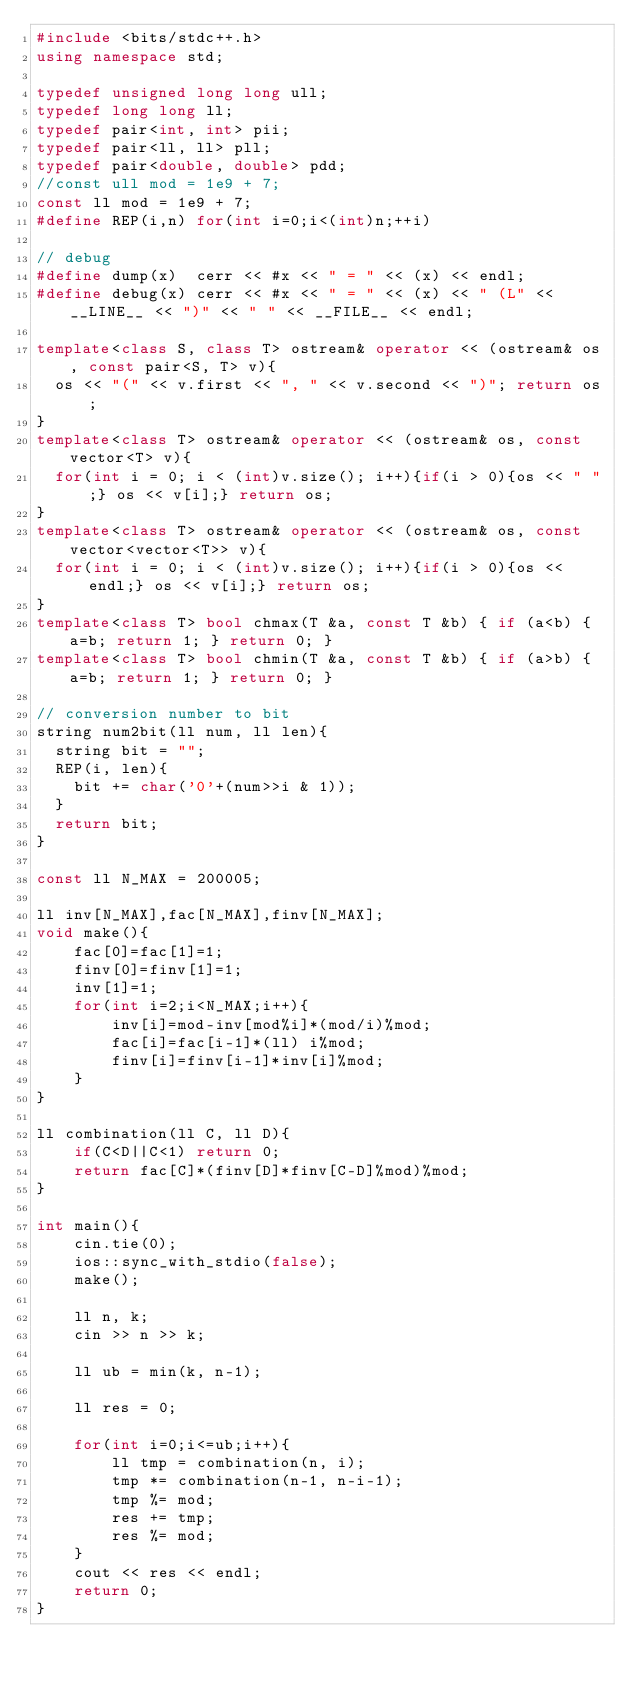<code> <loc_0><loc_0><loc_500><loc_500><_C++_>#include <bits/stdc++.h>
using namespace std;

typedef unsigned long long ull;
typedef long long ll;
typedef pair<int, int> pii;
typedef pair<ll, ll> pll;
typedef pair<double, double> pdd;
//const ull mod = 1e9 + 7;
const ll mod = 1e9 + 7;
#define REP(i,n) for(int i=0;i<(int)n;++i)

// debug
#define dump(x)  cerr << #x << " = " << (x) << endl;
#define debug(x) cerr << #x << " = " << (x) << " (L" << __LINE__ << ")" << " " << __FILE__ << endl;

template<class S, class T> ostream& operator << (ostream& os, const pair<S, T> v){
  os << "(" << v.first << ", " << v.second << ")"; return os;
}
template<class T> ostream& operator << (ostream& os, const vector<T> v){
  for(int i = 0; i < (int)v.size(); i++){if(i > 0){os << " ";} os << v[i];} return os;
}
template<class T> ostream& operator << (ostream& os, const vector<vector<T>> v){
  for(int i = 0; i < (int)v.size(); i++){if(i > 0){os << endl;} os << v[i];} return os;
}
template<class T> bool chmax(T &a, const T &b) { if (a<b) { a=b; return 1; } return 0; }
template<class T> bool chmin(T &a, const T &b) { if (a>b) { a=b; return 1; } return 0; }

// conversion number to bit
string num2bit(ll num, ll len){
  string bit = "";
  REP(i, len){
    bit += char('0'+(num>>i & 1));
  }
  return bit;
}

const ll N_MAX = 200005;

ll inv[N_MAX],fac[N_MAX],finv[N_MAX];
void make(){
    fac[0]=fac[1]=1;
    finv[0]=finv[1]=1;
    inv[1]=1;
    for(int i=2;i<N_MAX;i++){
        inv[i]=mod-inv[mod%i]*(mod/i)%mod;
        fac[i]=fac[i-1]*(ll) i%mod;
        finv[i]=finv[i-1]*inv[i]%mod;
    }
}

ll combination(ll C, ll D){
    if(C<D||C<1) return 0;
    return fac[C]*(finv[D]*finv[C-D]%mod)%mod;
}

int main(){
    cin.tie(0);
    ios::sync_with_stdio(false);
    make();

    ll n, k;
    cin >> n >> k;

    ll ub = min(k, n-1);

    ll res = 0;

    for(int i=0;i<=ub;i++){
    	ll tmp = combination(n, i);
    	tmp *= combination(n-1, n-i-1);
    	tmp %= mod;
    	res += tmp;
    	res %= mod;
    }
    cout << res << endl;
    return 0;
}</code> 